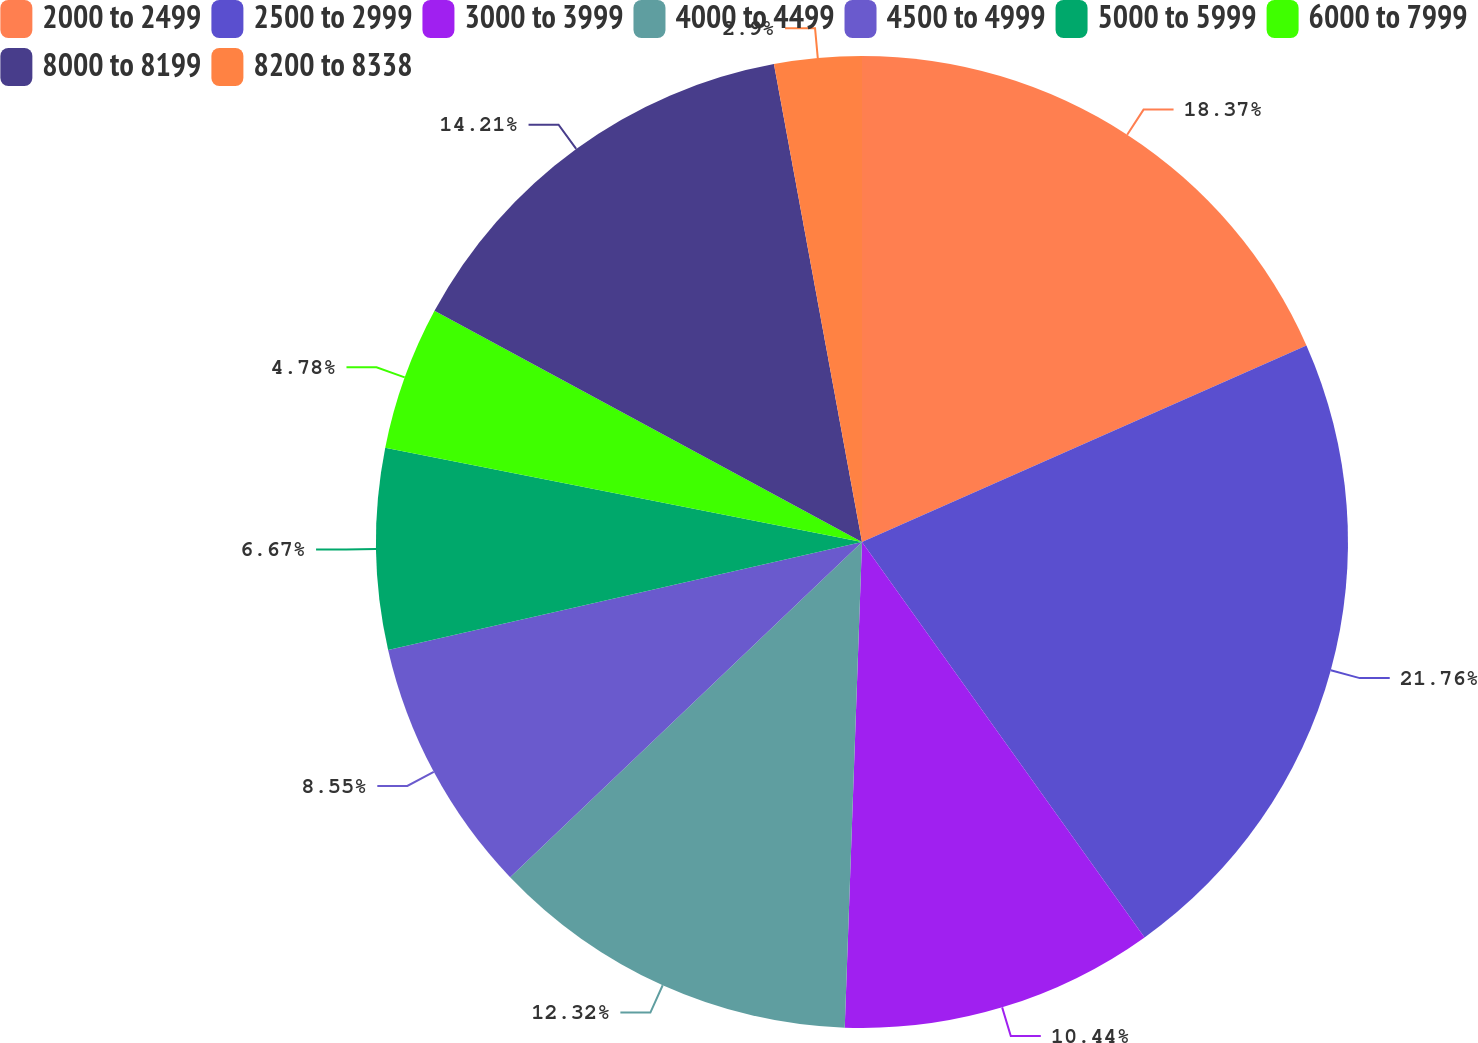Convert chart. <chart><loc_0><loc_0><loc_500><loc_500><pie_chart><fcel>2000 to 2499<fcel>2500 to 2999<fcel>3000 to 3999<fcel>4000 to 4499<fcel>4500 to 4999<fcel>5000 to 5999<fcel>6000 to 7999<fcel>8000 to 8199<fcel>8200 to 8338<nl><fcel>18.37%<fcel>21.75%<fcel>10.44%<fcel>12.32%<fcel>8.55%<fcel>6.67%<fcel>4.78%<fcel>14.21%<fcel>2.9%<nl></chart> 